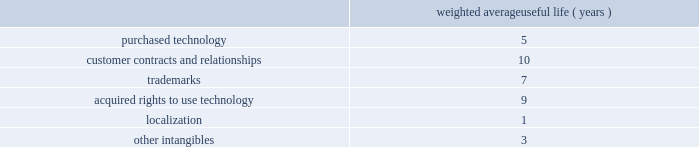Goodwill is assigned to one or more reporting segments on the date of acquisition .
We evaluate goodwill for impairment by comparing the fair value of each of our reporting segments to its carrying value , including the associated goodwill .
To determine the fair values , we use the market approach based on comparable publicly traded companies in similar lines of businesses and the income approach based on estimated discounted future cash flows .
Our cash flow assumptions consider historical and forecasted revenue , operating costs and other relevant factors .
We amortize intangible assets with finite lives over their estimated useful lives and review them for impairment whenever an impairment indicator exists .
We continually monitor events and changes in circumstances that could indicate carrying amounts of our long-lived assets , including our intangible assets may not be recoverable .
When such events or changes in circumstances occur , we assess recoverability by determining whether the carrying value of such assets will be recovered through the undiscounted expected future cash flows .
If the future undiscounted cash flows are less than the carrying amount of these assets , we recognize an impairment loss based on any excess of the carrying amount over the fair value of the assets .
We did not recognize any intangible asset impairment charges in fiscal 2012 , 2011 or 2010 .
Our intangible assets are amortized over their estimated useful lives of 1 to 13 years .
Amortization is based on the pattern in which the economic benefits of the intangible asset will be consumed .
The weighted average useful lives of our intangible assets was as follows : weighted average useful life ( years ) .
Software development costs capitalization of software development costs for software to be sold , leased , or otherwise marketed begins upon the establishment of technological feasibility , which is generally the completion of a working prototype that has been certified as having no critical bugs and is a release candidate .
Amortization begins once the software is ready for its intended use , generally based on the pattern in which the economic benefits will be consumed .
To date , software development costs incurred between completion of a working prototype and general availability of the related product have not been material .
Internal use software we capitalize costs associated with customized internal-use software systems that have reached the application development stage .
Such capitalized costs include external direct costs utilized in developing or obtaining the applications and payroll and payroll-related expenses for employees , who are directly associated with the development of the applications .
Capitalization of such costs begins when the preliminary project stage is complete and ceases at the point in which the project is substantially complete and is ready for its intended purpose .
Income taxes we use the asset and liability method of accounting for income taxes .
Under this method , income tax expense is recognized for the amount of taxes payable or refundable for the current year .
In addition , deferred tax assets and liabilities are recognized for expected future tax consequences of temporary differences between the financial reporting and tax bases of assets and liabilities , and for operating losses and tax credit carryforwards .
We record a valuation allowance to reduce deferred tax assets to an amount for which realization is more likely than not .
Table of contents adobe systems incorporated notes to consolidated financial statements ( continued ) .
What is the yearly amortization rate related to customer contracts and relationships? 
Computations: (100 / 10)
Answer: 10.0. Goodwill is assigned to one or more reporting segments on the date of acquisition .
We evaluate goodwill for impairment by comparing the fair value of each of our reporting segments to its carrying value , including the associated goodwill .
To determine the fair values , we use the market approach based on comparable publicly traded companies in similar lines of businesses and the income approach based on estimated discounted future cash flows .
Our cash flow assumptions consider historical and forecasted revenue , operating costs and other relevant factors .
We amortize intangible assets with finite lives over their estimated useful lives and review them for impairment whenever an impairment indicator exists .
We continually monitor events and changes in circumstances that could indicate carrying amounts of our long-lived assets , including our intangible assets may not be recoverable .
When such events or changes in circumstances occur , we assess recoverability by determining whether the carrying value of such assets will be recovered through the undiscounted expected future cash flows .
If the future undiscounted cash flows are less than the carrying amount of these assets , we recognize an impairment loss based on any excess of the carrying amount over the fair value of the assets .
We did not recognize any intangible asset impairment charges in fiscal 2012 , 2011 or 2010 .
Our intangible assets are amortized over their estimated useful lives of 1 to 13 years .
Amortization is based on the pattern in which the economic benefits of the intangible asset will be consumed .
The weighted average useful lives of our intangible assets was as follows : weighted average useful life ( years ) .
Software development costs capitalization of software development costs for software to be sold , leased , or otherwise marketed begins upon the establishment of technological feasibility , which is generally the completion of a working prototype that has been certified as having no critical bugs and is a release candidate .
Amortization begins once the software is ready for its intended use , generally based on the pattern in which the economic benefits will be consumed .
To date , software development costs incurred between completion of a working prototype and general availability of the related product have not been material .
Internal use software we capitalize costs associated with customized internal-use software systems that have reached the application development stage .
Such capitalized costs include external direct costs utilized in developing or obtaining the applications and payroll and payroll-related expenses for employees , who are directly associated with the development of the applications .
Capitalization of such costs begins when the preliminary project stage is complete and ceases at the point in which the project is substantially complete and is ready for its intended purpose .
Income taxes we use the asset and liability method of accounting for income taxes .
Under this method , income tax expense is recognized for the amount of taxes payable or refundable for the current year .
In addition , deferred tax assets and liabilities are recognized for expected future tax consequences of temporary differences between the financial reporting and tax bases of assets and liabilities , and for operating losses and tax credit carryforwards .
We record a valuation allowance to reduce deferred tax assets to an amount for which realization is more likely than not .
Table of contents adobe systems incorporated notes to consolidated financial statements ( continued ) .
What is the yearly amortization rate related to other intangibles? 
Computations: (100 / 3)
Answer: 33.33333. 